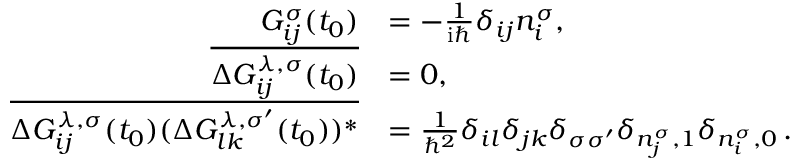Convert formula to latex. <formula><loc_0><loc_0><loc_500><loc_500>\begin{array} { r l } { G _ { i j } ^ { \sigma } ( t _ { 0 } ) } & { = - \frac { 1 } { i } \delta _ { i j } n _ { i } ^ { \sigma } , } \\ { \overline { { \Delta G _ { i j } ^ { \lambda , \sigma } ( t _ { 0 } ) } } } & { = 0 , } \\ { \overline { { \Delta G _ { i j } ^ { \lambda , \sigma } ( t _ { 0 } ) ( \Delta G _ { l k } ^ { \lambda , \sigma ^ { \prime } } ( t _ { 0 } ) ) ^ { * } } } } & { = \frac { 1 } { \hbar { ^ } { 2 } } \delta _ { i l } \delta _ { j k } \delta _ { \sigma \sigma ^ { \prime } } \delta _ { n _ { j } ^ { \sigma } , 1 } \delta _ { n _ { i } ^ { \sigma } , 0 } \, . } \end{array}</formula> 